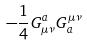Convert formula to latex. <formula><loc_0><loc_0><loc_500><loc_500>- \frac { 1 } { 4 } G _ { \mu \nu } ^ { a } G _ { a } ^ { \mu \nu }</formula> 